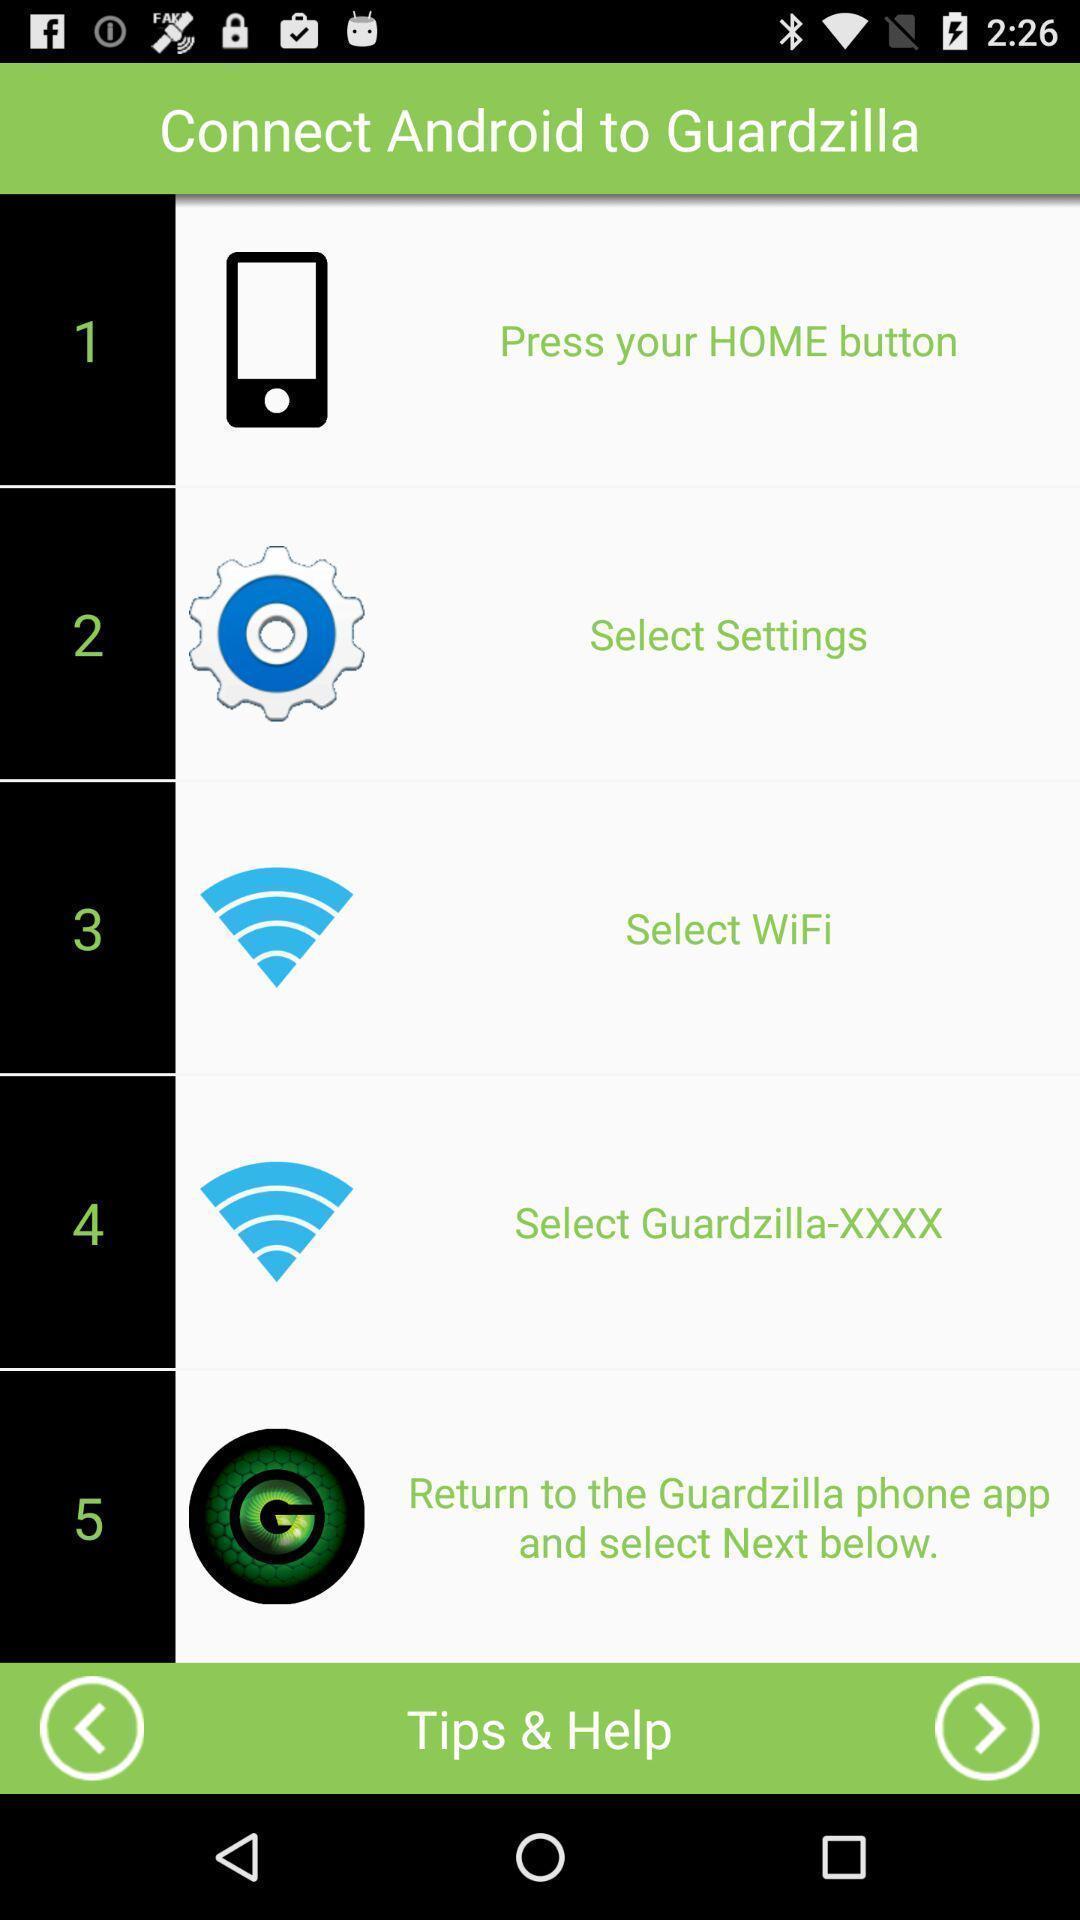Summarize the information in this screenshot. Page displaying with list of different options. 